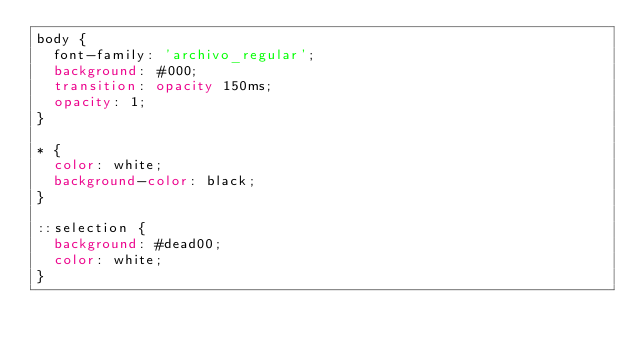<code> <loc_0><loc_0><loc_500><loc_500><_CSS_>body {
  font-family: 'archivo_regular';
  background: #000;
  transition: opacity 150ms;
  opacity: 1;
}

* {
  color: white;
  background-color: black;
}

::selection {
  background: #dead00;
  color: white;
}
</code> 